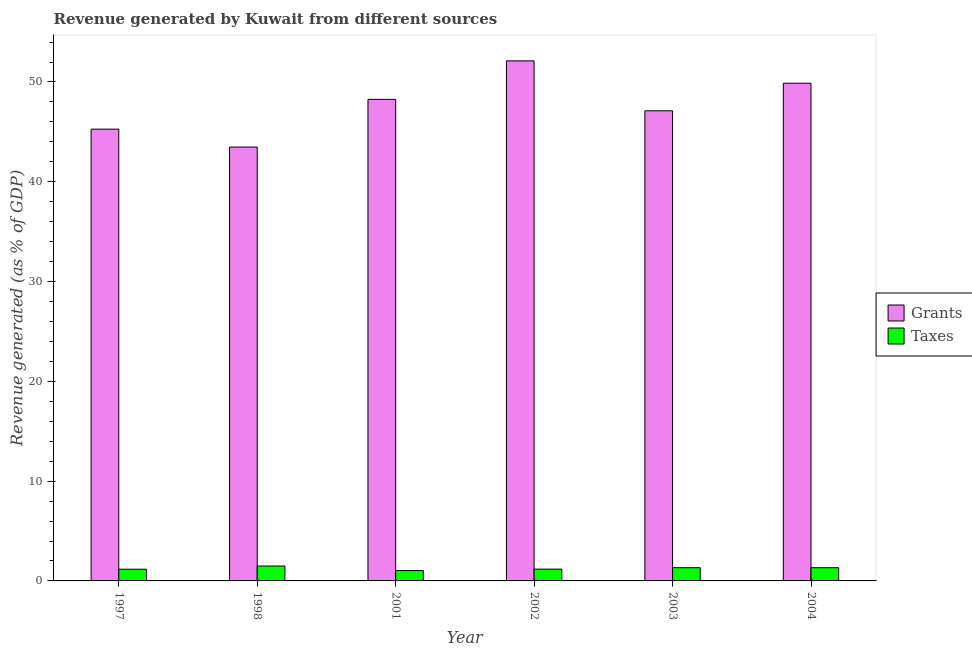How many groups of bars are there?
Your answer should be compact. 6. Are the number of bars per tick equal to the number of legend labels?
Offer a very short reply. Yes. How many bars are there on the 1st tick from the left?
Offer a very short reply. 2. How many bars are there on the 4th tick from the right?
Provide a succinct answer. 2. What is the revenue generated by taxes in 2001?
Give a very brief answer. 1.04. Across all years, what is the maximum revenue generated by grants?
Your response must be concise. 52.11. Across all years, what is the minimum revenue generated by grants?
Provide a short and direct response. 43.48. What is the total revenue generated by taxes in the graph?
Keep it short and to the point. 7.53. What is the difference between the revenue generated by taxes in 1997 and that in 2003?
Keep it short and to the point. -0.15. What is the difference between the revenue generated by grants in 1997 and the revenue generated by taxes in 2001?
Your answer should be compact. -2.98. What is the average revenue generated by grants per year?
Make the answer very short. 47.68. What is the ratio of the revenue generated by taxes in 1997 to that in 2004?
Your response must be concise. 0.89. Is the revenue generated by grants in 1997 less than that in 2004?
Make the answer very short. Yes. What is the difference between the highest and the second highest revenue generated by taxes?
Provide a short and direct response. 0.17. What is the difference between the highest and the lowest revenue generated by grants?
Offer a very short reply. 8.63. Is the sum of the revenue generated by grants in 1997 and 2002 greater than the maximum revenue generated by taxes across all years?
Give a very brief answer. Yes. What does the 2nd bar from the left in 2003 represents?
Ensure brevity in your answer.  Taxes. What does the 2nd bar from the right in 2002 represents?
Your answer should be very brief. Grants. How many years are there in the graph?
Ensure brevity in your answer.  6. Does the graph contain any zero values?
Give a very brief answer. No. Does the graph contain grids?
Provide a succinct answer. No. Where does the legend appear in the graph?
Your answer should be compact. Center right. How are the legend labels stacked?
Make the answer very short. Vertical. What is the title of the graph?
Ensure brevity in your answer.  Revenue generated by Kuwait from different sources. Does "GDP" appear as one of the legend labels in the graph?
Give a very brief answer. No. What is the label or title of the X-axis?
Your response must be concise. Year. What is the label or title of the Y-axis?
Give a very brief answer. Revenue generated (as % of GDP). What is the Revenue generated (as % of GDP) in Grants in 1997?
Give a very brief answer. 45.27. What is the Revenue generated (as % of GDP) in Taxes in 1997?
Keep it short and to the point. 1.17. What is the Revenue generated (as % of GDP) of Grants in 1998?
Your response must be concise. 43.48. What is the Revenue generated (as % of GDP) of Taxes in 1998?
Provide a succinct answer. 1.49. What is the Revenue generated (as % of GDP) of Grants in 2001?
Offer a very short reply. 48.26. What is the Revenue generated (as % of GDP) in Taxes in 2001?
Your answer should be very brief. 1.04. What is the Revenue generated (as % of GDP) in Grants in 2002?
Offer a terse response. 52.11. What is the Revenue generated (as % of GDP) in Taxes in 2002?
Keep it short and to the point. 1.18. What is the Revenue generated (as % of GDP) in Grants in 2003?
Make the answer very short. 47.11. What is the Revenue generated (as % of GDP) of Taxes in 2003?
Provide a short and direct response. 1.32. What is the Revenue generated (as % of GDP) in Grants in 2004?
Your answer should be compact. 49.88. What is the Revenue generated (as % of GDP) of Taxes in 2004?
Keep it short and to the point. 1.32. Across all years, what is the maximum Revenue generated (as % of GDP) in Grants?
Your response must be concise. 52.11. Across all years, what is the maximum Revenue generated (as % of GDP) of Taxes?
Keep it short and to the point. 1.49. Across all years, what is the minimum Revenue generated (as % of GDP) of Grants?
Offer a terse response. 43.48. Across all years, what is the minimum Revenue generated (as % of GDP) in Taxes?
Your response must be concise. 1.04. What is the total Revenue generated (as % of GDP) in Grants in the graph?
Your response must be concise. 286.11. What is the total Revenue generated (as % of GDP) in Taxes in the graph?
Provide a succinct answer. 7.53. What is the difference between the Revenue generated (as % of GDP) of Grants in 1997 and that in 1998?
Your answer should be compact. 1.79. What is the difference between the Revenue generated (as % of GDP) of Taxes in 1997 and that in 1998?
Ensure brevity in your answer.  -0.32. What is the difference between the Revenue generated (as % of GDP) of Grants in 1997 and that in 2001?
Offer a terse response. -2.98. What is the difference between the Revenue generated (as % of GDP) of Taxes in 1997 and that in 2001?
Keep it short and to the point. 0.14. What is the difference between the Revenue generated (as % of GDP) in Grants in 1997 and that in 2002?
Provide a short and direct response. -6.84. What is the difference between the Revenue generated (as % of GDP) of Taxes in 1997 and that in 2002?
Ensure brevity in your answer.  -0.01. What is the difference between the Revenue generated (as % of GDP) of Grants in 1997 and that in 2003?
Your answer should be compact. -1.84. What is the difference between the Revenue generated (as % of GDP) in Taxes in 1997 and that in 2003?
Provide a succinct answer. -0.15. What is the difference between the Revenue generated (as % of GDP) in Grants in 1997 and that in 2004?
Offer a very short reply. -4.6. What is the difference between the Revenue generated (as % of GDP) in Taxes in 1997 and that in 2004?
Ensure brevity in your answer.  -0.15. What is the difference between the Revenue generated (as % of GDP) of Grants in 1998 and that in 2001?
Give a very brief answer. -4.78. What is the difference between the Revenue generated (as % of GDP) of Taxes in 1998 and that in 2001?
Offer a terse response. 0.46. What is the difference between the Revenue generated (as % of GDP) in Grants in 1998 and that in 2002?
Ensure brevity in your answer.  -8.63. What is the difference between the Revenue generated (as % of GDP) of Taxes in 1998 and that in 2002?
Your answer should be very brief. 0.31. What is the difference between the Revenue generated (as % of GDP) in Grants in 1998 and that in 2003?
Your answer should be compact. -3.63. What is the difference between the Revenue generated (as % of GDP) of Taxes in 1998 and that in 2003?
Provide a succinct answer. 0.17. What is the difference between the Revenue generated (as % of GDP) in Grants in 1998 and that in 2004?
Ensure brevity in your answer.  -6.4. What is the difference between the Revenue generated (as % of GDP) of Taxes in 1998 and that in 2004?
Make the answer very short. 0.17. What is the difference between the Revenue generated (as % of GDP) in Grants in 2001 and that in 2002?
Offer a very short reply. -3.86. What is the difference between the Revenue generated (as % of GDP) of Taxes in 2001 and that in 2002?
Keep it short and to the point. -0.14. What is the difference between the Revenue generated (as % of GDP) in Grants in 2001 and that in 2003?
Your answer should be very brief. 1.15. What is the difference between the Revenue generated (as % of GDP) in Taxes in 2001 and that in 2003?
Provide a succinct answer. -0.29. What is the difference between the Revenue generated (as % of GDP) in Grants in 2001 and that in 2004?
Make the answer very short. -1.62. What is the difference between the Revenue generated (as % of GDP) of Taxes in 2001 and that in 2004?
Keep it short and to the point. -0.29. What is the difference between the Revenue generated (as % of GDP) in Grants in 2002 and that in 2003?
Make the answer very short. 5.01. What is the difference between the Revenue generated (as % of GDP) in Taxes in 2002 and that in 2003?
Offer a terse response. -0.14. What is the difference between the Revenue generated (as % of GDP) in Grants in 2002 and that in 2004?
Give a very brief answer. 2.24. What is the difference between the Revenue generated (as % of GDP) in Taxes in 2002 and that in 2004?
Provide a succinct answer. -0.14. What is the difference between the Revenue generated (as % of GDP) of Grants in 2003 and that in 2004?
Provide a short and direct response. -2.77. What is the difference between the Revenue generated (as % of GDP) in Grants in 1997 and the Revenue generated (as % of GDP) in Taxes in 1998?
Offer a very short reply. 43.78. What is the difference between the Revenue generated (as % of GDP) in Grants in 1997 and the Revenue generated (as % of GDP) in Taxes in 2001?
Keep it short and to the point. 44.24. What is the difference between the Revenue generated (as % of GDP) of Grants in 1997 and the Revenue generated (as % of GDP) of Taxes in 2002?
Offer a terse response. 44.09. What is the difference between the Revenue generated (as % of GDP) of Grants in 1997 and the Revenue generated (as % of GDP) of Taxes in 2003?
Keep it short and to the point. 43.95. What is the difference between the Revenue generated (as % of GDP) in Grants in 1997 and the Revenue generated (as % of GDP) in Taxes in 2004?
Your answer should be compact. 43.95. What is the difference between the Revenue generated (as % of GDP) in Grants in 1998 and the Revenue generated (as % of GDP) in Taxes in 2001?
Your response must be concise. 42.44. What is the difference between the Revenue generated (as % of GDP) of Grants in 1998 and the Revenue generated (as % of GDP) of Taxes in 2002?
Keep it short and to the point. 42.3. What is the difference between the Revenue generated (as % of GDP) of Grants in 1998 and the Revenue generated (as % of GDP) of Taxes in 2003?
Make the answer very short. 42.16. What is the difference between the Revenue generated (as % of GDP) of Grants in 1998 and the Revenue generated (as % of GDP) of Taxes in 2004?
Your answer should be compact. 42.16. What is the difference between the Revenue generated (as % of GDP) of Grants in 2001 and the Revenue generated (as % of GDP) of Taxes in 2002?
Ensure brevity in your answer.  47.08. What is the difference between the Revenue generated (as % of GDP) of Grants in 2001 and the Revenue generated (as % of GDP) of Taxes in 2003?
Provide a short and direct response. 46.93. What is the difference between the Revenue generated (as % of GDP) of Grants in 2001 and the Revenue generated (as % of GDP) of Taxes in 2004?
Keep it short and to the point. 46.93. What is the difference between the Revenue generated (as % of GDP) in Grants in 2002 and the Revenue generated (as % of GDP) in Taxes in 2003?
Your answer should be compact. 50.79. What is the difference between the Revenue generated (as % of GDP) in Grants in 2002 and the Revenue generated (as % of GDP) in Taxes in 2004?
Ensure brevity in your answer.  50.79. What is the difference between the Revenue generated (as % of GDP) of Grants in 2003 and the Revenue generated (as % of GDP) of Taxes in 2004?
Make the answer very short. 45.78. What is the average Revenue generated (as % of GDP) of Grants per year?
Provide a short and direct response. 47.68. What is the average Revenue generated (as % of GDP) of Taxes per year?
Make the answer very short. 1.26. In the year 1997, what is the difference between the Revenue generated (as % of GDP) of Grants and Revenue generated (as % of GDP) of Taxes?
Your response must be concise. 44.1. In the year 1998, what is the difference between the Revenue generated (as % of GDP) in Grants and Revenue generated (as % of GDP) in Taxes?
Ensure brevity in your answer.  41.99. In the year 2001, what is the difference between the Revenue generated (as % of GDP) in Grants and Revenue generated (as % of GDP) in Taxes?
Your answer should be compact. 47.22. In the year 2002, what is the difference between the Revenue generated (as % of GDP) in Grants and Revenue generated (as % of GDP) in Taxes?
Keep it short and to the point. 50.93. In the year 2003, what is the difference between the Revenue generated (as % of GDP) of Grants and Revenue generated (as % of GDP) of Taxes?
Provide a succinct answer. 45.78. In the year 2004, what is the difference between the Revenue generated (as % of GDP) of Grants and Revenue generated (as % of GDP) of Taxes?
Provide a short and direct response. 48.55. What is the ratio of the Revenue generated (as % of GDP) in Grants in 1997 to that in 1998?
Your answer should be very brief. 1.04. What is the ratio of the Revenue generated (as % of GDP) of Taxes in 1997 to that in 1998?
Offer a terse response. 0.79. What is the ratio of the Revenue generated (as % of GDP) in Grants in 1997 to that in 2001?
Keep it short and to the point. 0.94. What is the ratio of the Revenue generated (as % of GDP) in Taxes in 1997 to that in 2001?
Your answer should be very brief. 1.13. What is the ratio of the Revenue generated (as % of GDP) of Grants in 1997 to that in 2002?
Your answer should be very brief. 0.87. What is the ratio of the Revenue generated (as % of GDP) in Taxes in 1997 to that in 2002?
Provide a short and direct response. 0.99. What is the ratio of the Revenue generated (as % of GDP) of Grants in 1997 to that in 2003?
Provide a succinct answer. 0.96. What is the ratio of the Revenue generated (as % of GDP) of Taxes in 1997 to that in 2003?
Keep it short and to the point. 0.89. What is the ratio of the Revenue generated (as % of GDP) of Grants in 1997 to that in 2004?
Provide a succinct answer. 0.91. What is the ratio of the Revenue generated (as % of GDP) of Taxes in 1997 to that in 2004?
Keep it short and to the point. 0.89. What is the ratio of the Revenue generated (as % of GDP) in Grants in 1998 to that in 2001?
Ensure brevity in your answer.  0.9. What is the ratio of the Revenue generated (as % of GDP) in Taxes in 1998 to that in 2001?
Give a very brief answer. 1.44. What is the ratio of the Revenue generated (as % of GDP) of Grants in 1998 to that in 2002?
Keep it short and to the point. 0.83. What is the ratio of the Revenue generated (as % of GDP) in Taxes in 1998 to that in 2002?
Provide a succinct answer. 1.26. What is the ratio of the Revenue generated (as % of GDP) in Grants in 1998 to that in 2003?
Provide a succinct answer. 0.92. What is the ratio of the Revenue generated (as % of GDP) in Taxes in 1998 to that in 2003?
Provide a succinct answer. 1.13. What is the ratio of the Revenue generated (as % of GDP) in Grants in 1998 to that in 2004?
Make the answer very short. 0.87. What is the ratio of the Revenue generated (as % of GDP) in Taxes in 1998 to that in 2004?
Provide a succinct answer. 1.13. What is the ratio of the Revenue generated (as % of GDP) in Grants in 2001 to that in 2002?
Your answer should be compact. 0.93. What is the ratio of the Revenue generated (as % of GDP) in Taxes in 2001 to that in 2002?
Ensure brevity in your answer.  0.88. What is the ratio of the Revenue generated (as % of GDP) in Grants in 2001 to that in 2003?
Your response must be concise. 1.02. What is the ratio of the Revenue generated (as % of GDP) in Taxes in 2001 to that in 2003?
Provide a succinct answer. 0.78. What is the ratio of the Revenue generated (as % of GDP) of Grants in 2001 to that in 2004?
Your answer should be compact. 0.97. What is the ratio of the Revenue generated (as % of GDP) in Taxes in 2001 to that in 2004?
Provide a short and direct response. 0.78. What is the ratio of the Revenue generated (as % of GDP) in Grants in 2002 to that in 2003?
Provide a succinct answer. 1.11. What is the ratio of the Revenue generated (as % of GDP) of Taxes in 2002 to that in 2003?
Ensure brevity in your answer.  0.89. What is the ratio of the Revenue generated (as % of GDP) in Grants in 2002 to that in 2004?
Keep it short and to the point. 1.04. What is the ratio of the Revenue generated (as % of GDP) of Taxes in 2002 to that in 2004?
Keep it short and to the point. 0.89. What is the ratio of the Revenue generated (as % of GDP) of Grants in 2003 to that in 2004?
Offer a very short reply. 0.94. What is the difference between the highest and the second highest Revenue generated (as % of GDP) of Grants?
Give a very brief answer. 2.24. What is the difference between the highest and the second highest Revenue generated (as % of GDP) in Taxes?
Your response must be concise. 0.17. What is the difference between the highest and the lowest Revenue generated (as % of GDP) in Grants?
Offer a very short reply. 8.63. What is the difference between the highest and the lowest Revenue generated (as % of GDP) of Taxes?
Your response must be concise. 0.46. 